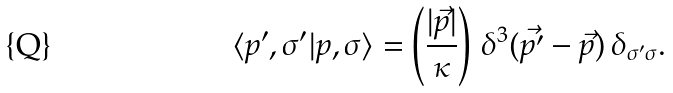<formula> <loc_0><loc_0><loc_500><loc_500>\langle p ^ { \prime } , \sigma ^ { \prime } | p , \sigma \rangle = \left ( \frac { | \vec { p } | } { \kappa } \right ) \, \delta ^ { 3 } ( \vec { p ^ { \prime } } - \vec { p } ) \, \delta _ { \sigma ^ { \prime } \sigma } .</formula> 